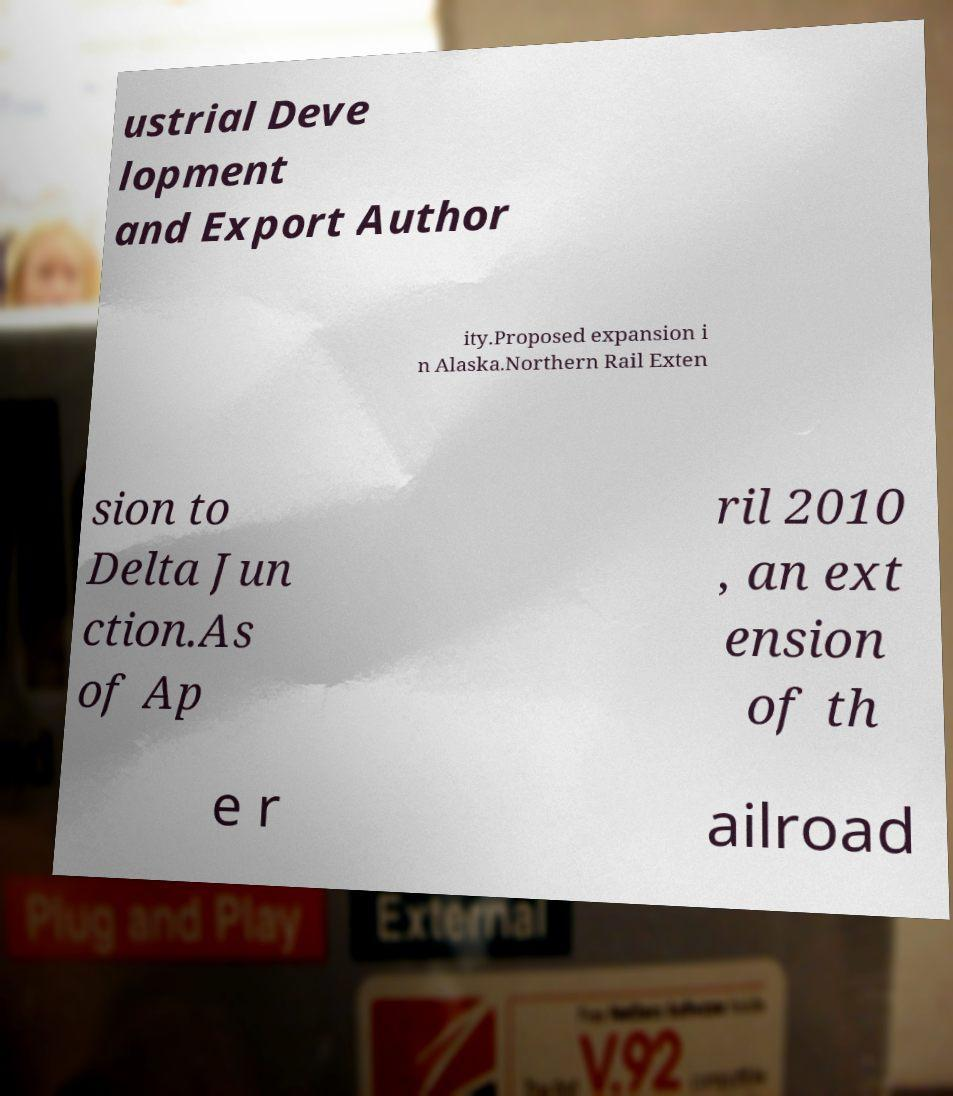I need the written content from this picture converted into text. Can you do that? ustrial Deve lopment and Export Author ity.Proposed expansion i n Alaska.Northern Rail Exten sion to Delta Jun ction.As of Ap ril 2010 , an ext ension of th e r ailroad 